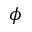<formula> <loc_0><loc_0><loc_500><loc_500>\phi</formula> 